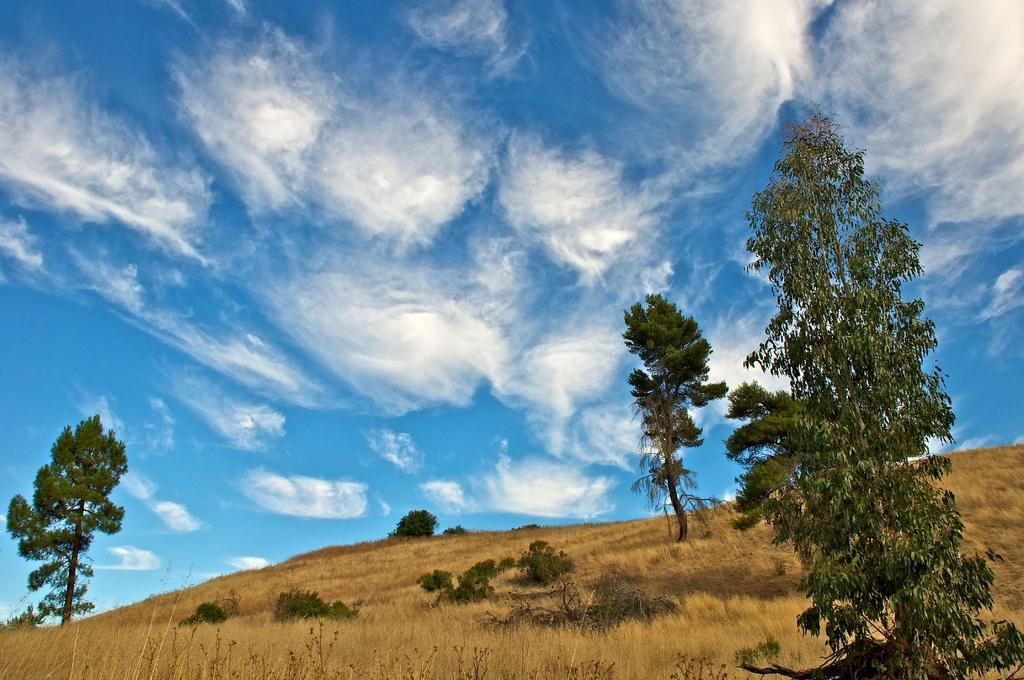What type of vegetation can be seen in the image? There are trees and plants in the image. What is the condition of the grass in the image? Dry grass is present in the image. How would you describe the sky in the image? The sky is cloudy and pale blue in the image. What type of quartz can be seen in the image? There is no quartz present in the image. Can you see a railway in the image? There is no railway present in the image. 